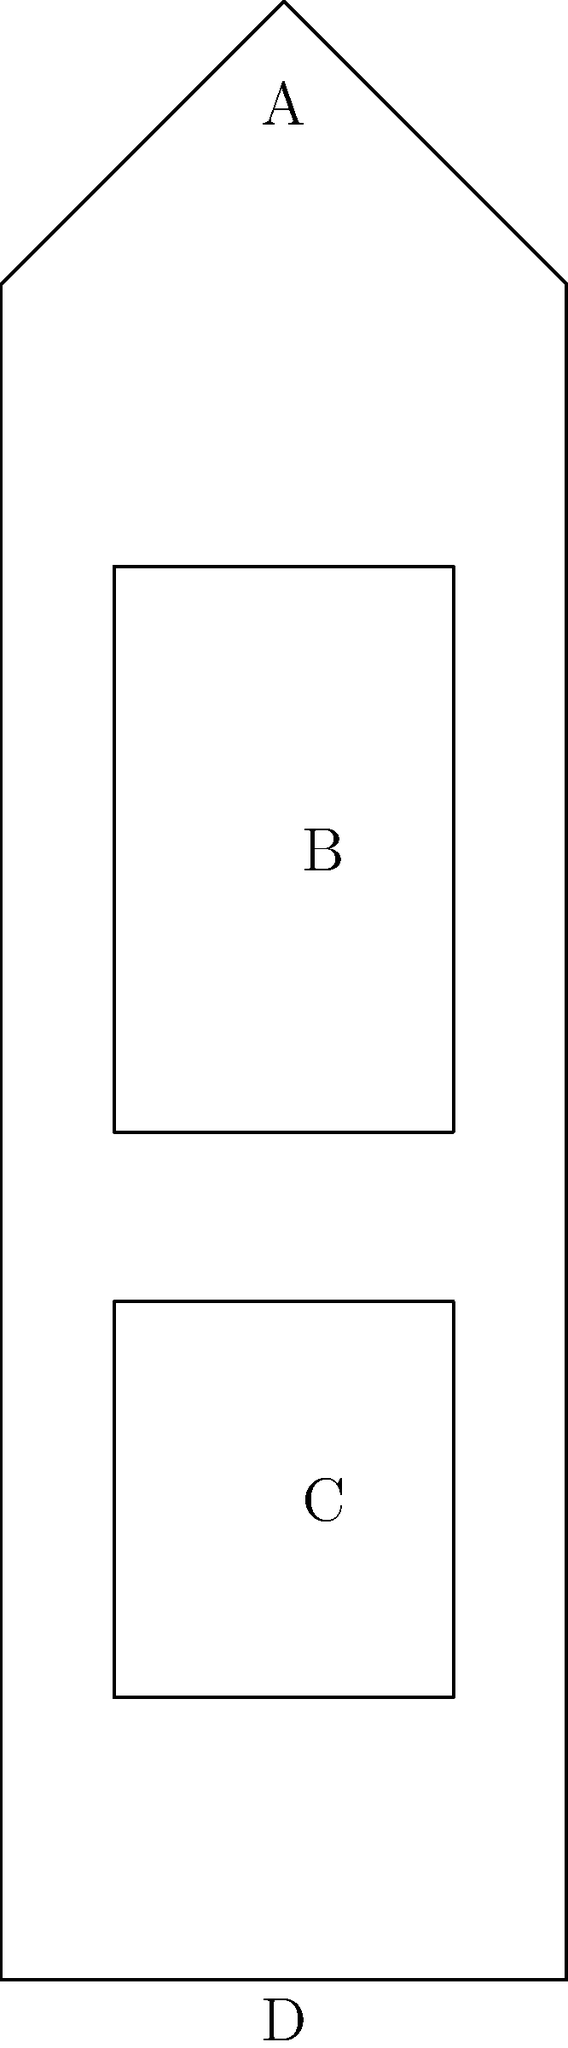In the cross-sectional view of a medieval cathedral shown above, identify the architectural elements labeled A, B, C, and D. Which of these elements was typically the most ornate and symbolically significant in Gothic cathedrals? To answer this question, we need to analyze each labeled part of the cathedral:

1. A: This is the roof or more specifically, the pitched roof. In Gothic cathedrals, this was often quite steep to allow for better drainage and to create a more imposing silhouette.

2. B: This represents the clerestory, a row of windows high up in the nave of the cathedral. The clerestory allowed more light into the building, a key feature of Gothic architecture.

3. C: This is the nave arcade, the lower level of the cathedral's main body. It typically consisted of a series of arches supported by columns or piers.

4. D: This is the floor of the cathedral.

Among these elements, the clerestory (B) was typically the most ornate and symbolically significant in Gothic cathedrals. Here's why:

1. Light symbolism: In medieval Christian theology, light was associated with the divine. The large clerestory windows allowed abundant light to enter the cathedral, symbolizing God's presence.

2. Stained glass: Clerestory windows often featured elaborate stained glass, depicting biblical stories and saints. These served both as decoration and as educational tools for the largely illiterate congregation.

3. Structural innovation: The large clerestory windows were made possible by Gothic architectural innovations like flying buttresses, which allowed for thinner walls and larger windows.

4. Visual focus: The clerestory, being high up, drew the eye upward, emphasizing the verticality of Gothic cathedrals and symbolically directing attention towards heaven.

While other parts of the cathedral were also important and could be ornate, the clerestory combined aesthetic beauty, structural innovation, and rich symbolism in a way that made it particularly significant in Gothic cathedral design.
Answer: Clerestory (B) 